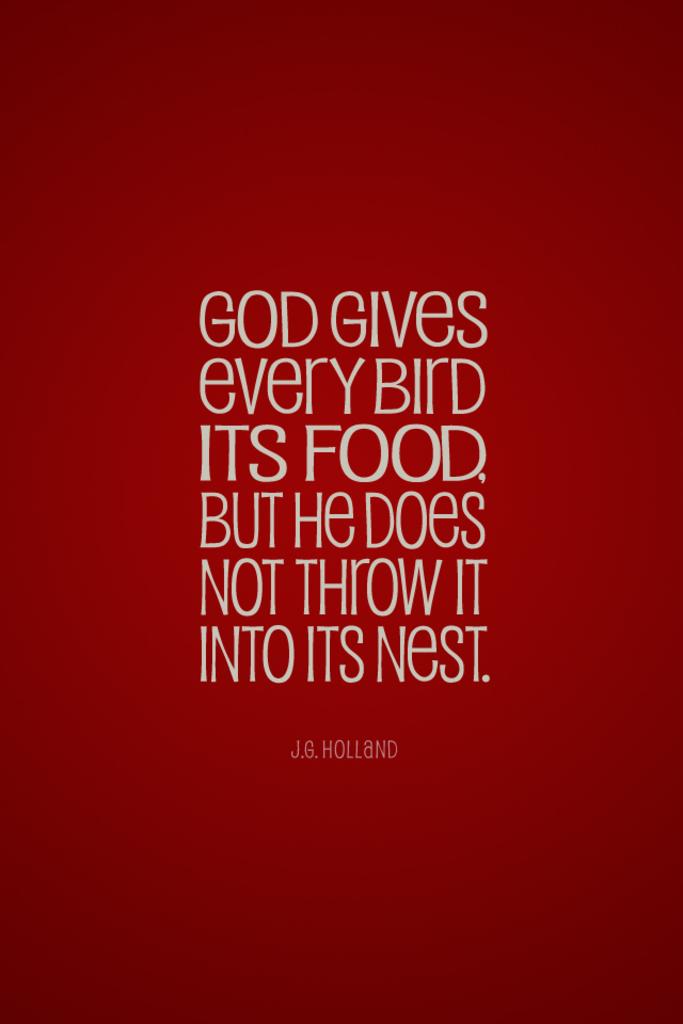Who was the author of this quote?
Provide a succinct answer. J.g. holland. What does god give every bird?
Offer a very short reply. Its food. 